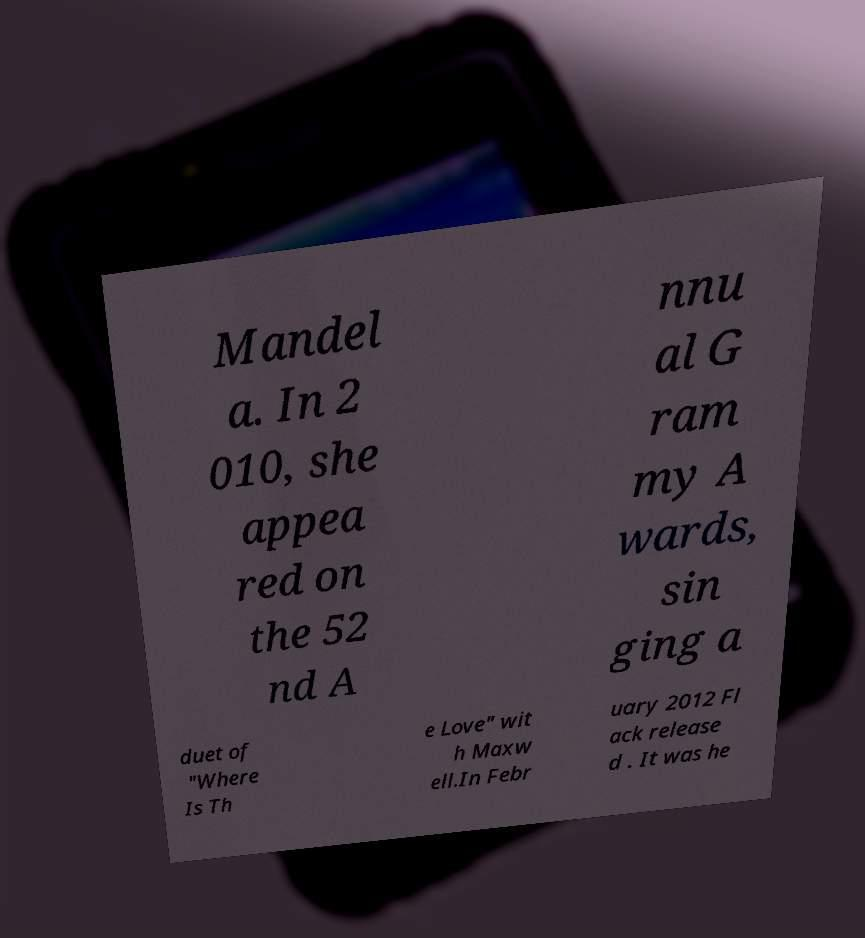There's text embedded in this image that I need extracted. Can you transcribe it verbatim? Mandel a. In 2 010, she appea red on the 52 nd A nnu al G ram my A wards, sin ging a duet of "Where Is Th e Love" wit h Maxw ell.In Febr uary 2012 Fl ack release d . It was he 